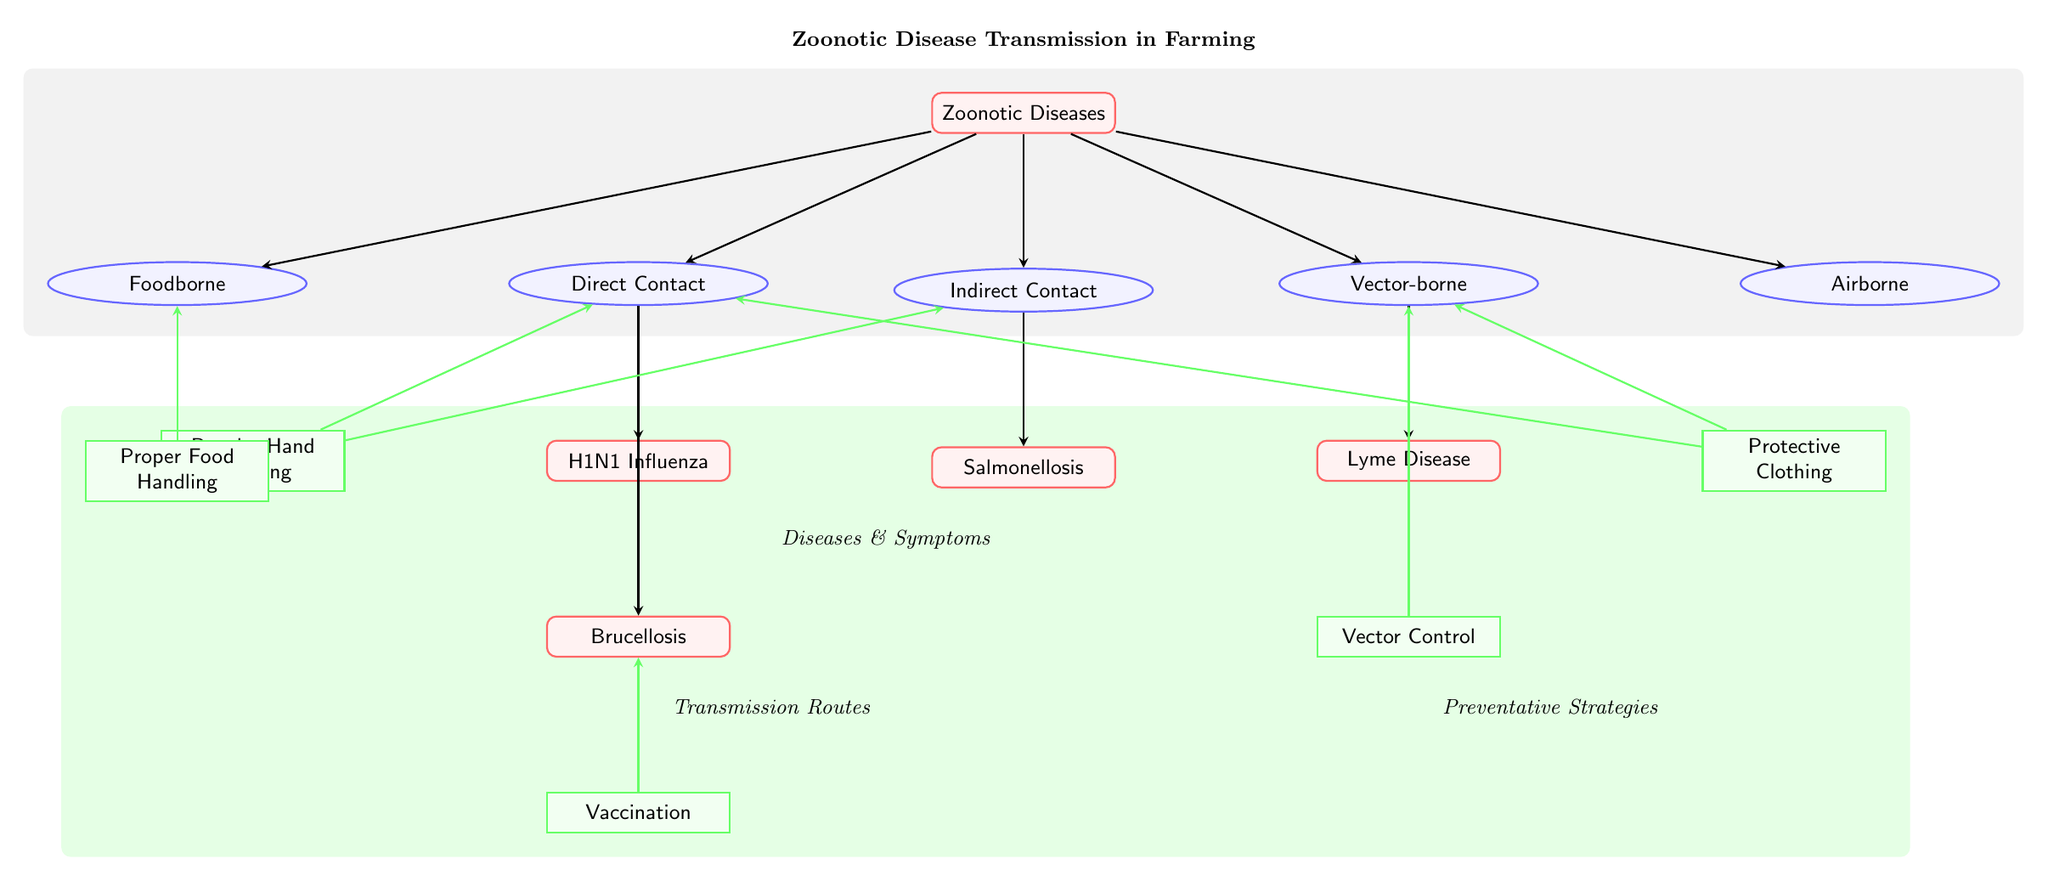What are the five transmission routes shown in the diagram? The diagram lists five specific transmission routes for zoonotic diseases: Direct Contact, Indirect Contact, Vector-borne, Foodborne, and Airborne. By locating the transmission nodes on the diagram, we can systematically identify all the routes listed.
Answer: Direct Contact, Indirect Contact, Vector-borne, Foodborne, Airborne Which disease is connected to Indirect Contact? Indirect Contact leads to the disease node for Salmonellosis in the diagram. Following the arrow from Indirect Contact to the disease node identifies this connection clearly.
Answer: Salmonellosis How many diseases are shown in the diagram? The diagram includes four disease nodes: H1N1 Influenza, Salmonellosis, Lyme Disease, and Brucellosis. Tallying the distinct disease nodes in the lower section of the diagram gives us this total.
Answer: 4 What preventative strategy connects to Brucellosis? The preventative strategy node for Vaccination connects to Brucellosis, as indicated by the green arrow leading from Vaccination to the corresponding disease node. This demonstrates the linkage of preventative measures to specific diseases.
Answer: Vaccination Which two diseases are connected to Direct Contact? The diseases connected to Direct Contact are H1N1 Influenza and Brucellosis. By following the arrows originating from the Direct Contact transmission node, we can observe both disease nodes.
Answer: H1N1 Influenza, Brucellosis What color represents the disease nodes in the diagram? The disease nodes are represented in red, shown by the red foreground and edge of the disease rectangles throughout the diagram. Color coding allows for quick visual identification of disease-related elements.
Answer: Red Which preventative strategy is linked to Vector-borne transmission? The preventative strategy connected to Vector-borne transmission is Vector Control, determined by tracing the arrow from Vector Control to the Vector-borne transmission node in the diagram. This indicates a specific preventative measure related to vector-borne diseases.
Answer: Vector Control How many preventative strategies are listed in the diagram? There are five preventative strategies listed: Regular Hand Washing, Protective Clothing, Proper Food Handling, Vaccination, and Vector Control. Counting each of the prevention nodes confirms this total.
Answer: 5 What does the gray background in the diagram indicate? The gray background encompasses the entire section of transmission routes, visually emphasizing the broader category of transmission ways for zoonotic diseases while separating it from disease and prevention areas of the diagram.
Answer: Transmission Routes 